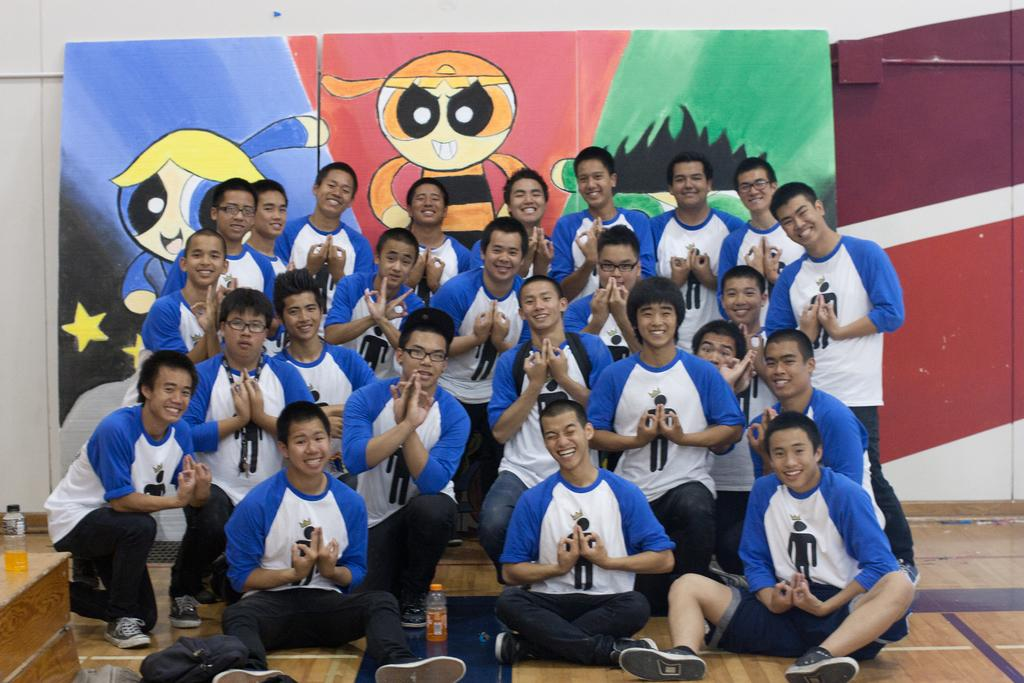How many people are in the image? There is a group of people in the image. What are the people wearing? The people are wearing the same t-shirts. What is the facial expression of the people in the image? The people are smiling. What can be seen near the people in the image? There are bottles visible in the image. What is present on the wall in the image? There is a wall in the image with boards on it. What is depicted on the boards? The boards have pictures of Powerpuff Girls. What type of business is being conducted in the image? There is no indication of a business being conducted in the image. Is there a sink visible in the image? No, there is no sink present in the image. 